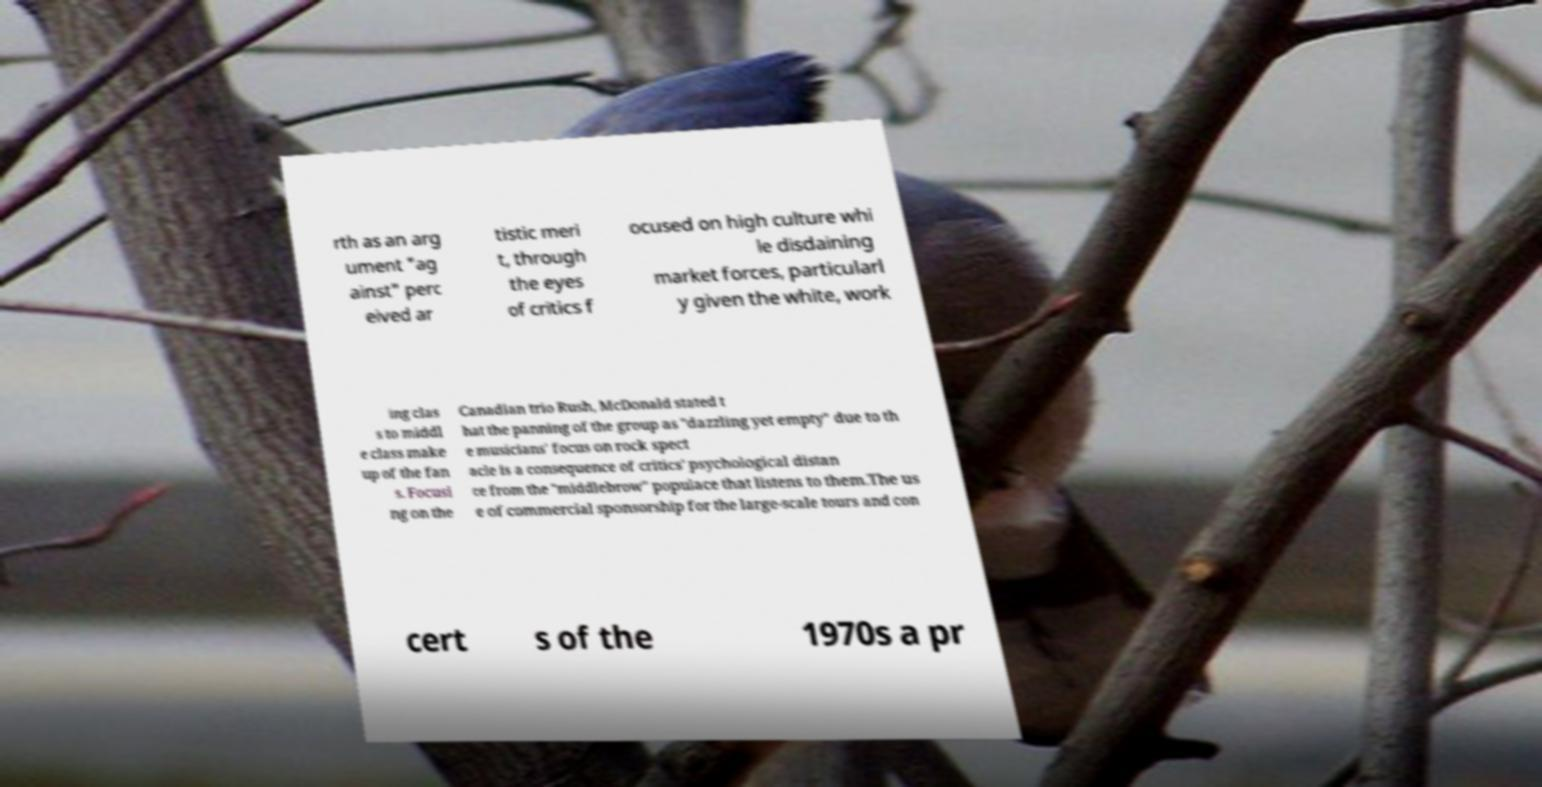There's text embedded in this image that I need extracted. Can you transcribe it verbatim? rth as an arg ument "ag ainst" perc eived ar tistic meri t, through the eyes of critics f ocused on high culture whi le disdaining market forces, particularl y given the white, work ing clas s to middl e class make up of the fan s. Focusi ng on the Canadian trio Rush, McDonald stated t hat the panning of the group as "dazzling yet empty" due to th e musicians' focus on rock spect acle is a consequence of critics' psychological distan ce from the "middlebrow" populace that listens to them.The us e of commercial sponsorship for the large-scale tours and con cert s of the 1970s a pr 